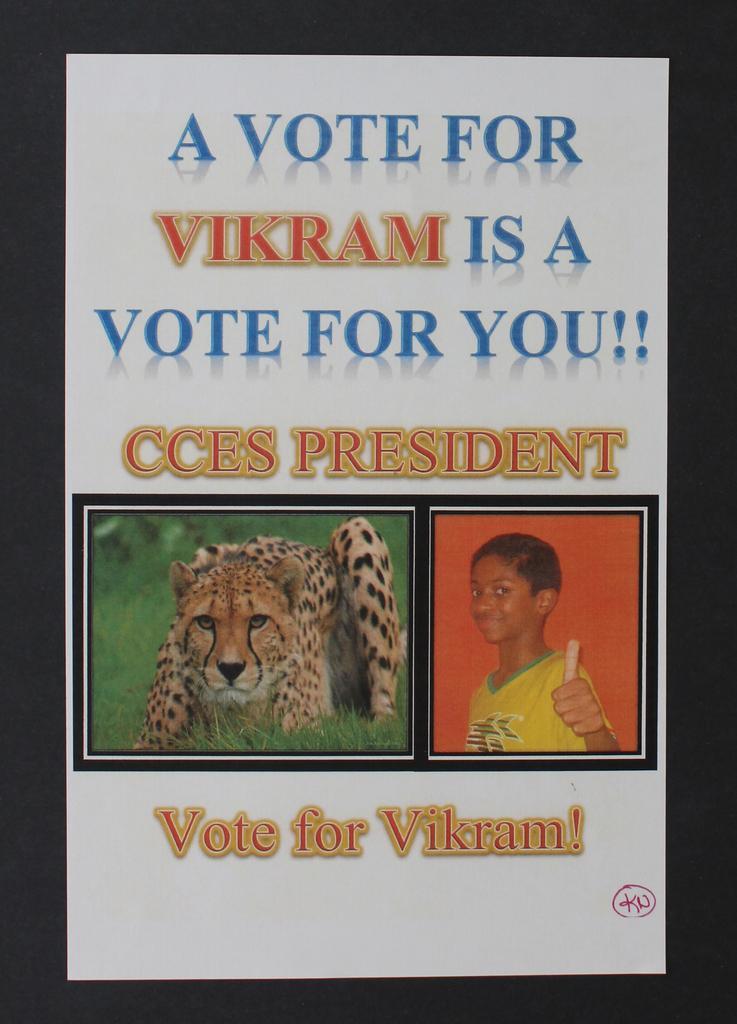How would you summarize this image in a sentence or two? In this picture we can see two pictures in the white paper, and some text is written in the paper. 